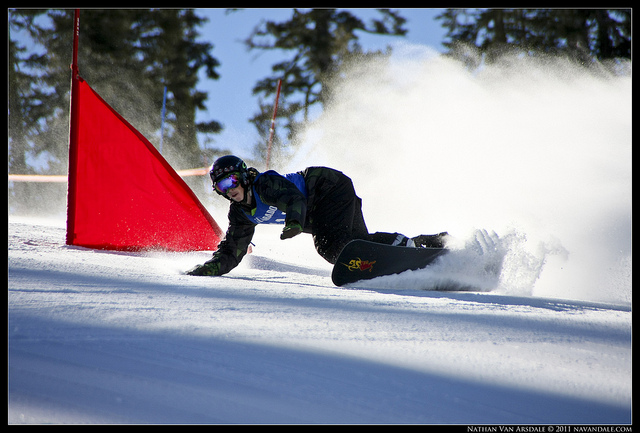Please transcribe the text in this image. NATHAN ARSISALE NAVANIDALE.COM 